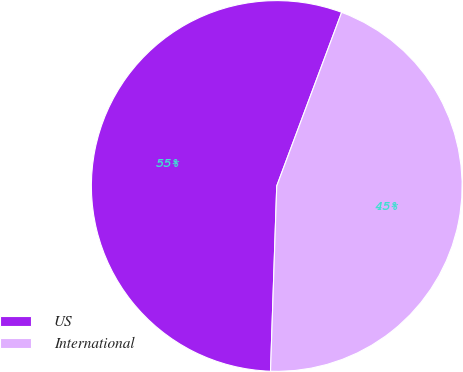Convert chart. <chart><loc_0><loc_0><loc_500><loc_500><pie_chart><fcel>US<fcel>International<nl><fcel>55.16%<fcel>44.84%<nl></chart> 